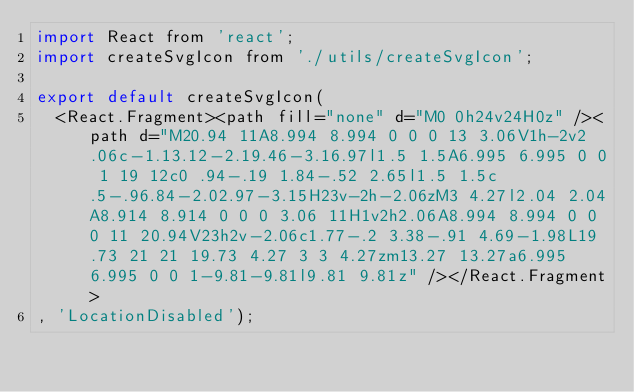<code> <loc_0><loc_0><loc_500><loc_500><_JavaScript_>import React from 'react';
import createSvgIcon from './utils/createSvgIcon';

export default createSvgIcon(
  <React.Fragment><path fill="none" d="M0 0h24v24H0z" /><path d="M20.94 11A8.994 8.994 0 0 0 13 3.06V1h-2v2.06c-1.13.12-2.19.46-3.16.97l1.5 1.5A6.995 6.995 0 0 1 19 12c0 .94-.19 1.84-.52 2.65l1.5 1.5c.5-.96.84-2.02.97-3.15H23v-2h-2.06zM3 4.27l2.04 2.04A8.914 8.914 0 0 0 3.06 11H1v2h2.06A8.994 8.994 0 0 0 11 20.94V23h2v-2.06c1.77-.2 3.38-.91 4.69-1.98L19.73 21 21 19.73 4.27 3 3 4.27zm13.27 13.27a6.995 6.995 0 0 1-9.81-9.81l9.81 9.81z" /></React.Fragment>
, 'LocationDisabled');
</code> 